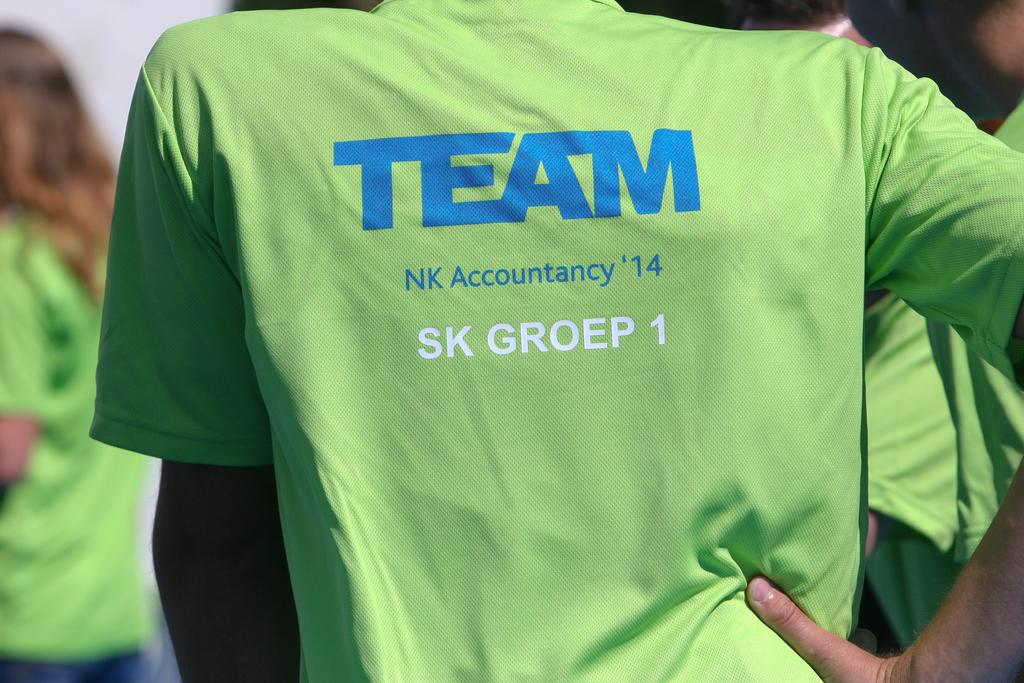Provide a one-sentence caption for the provided image. A member of group 1 stands with their hand on their hip. 